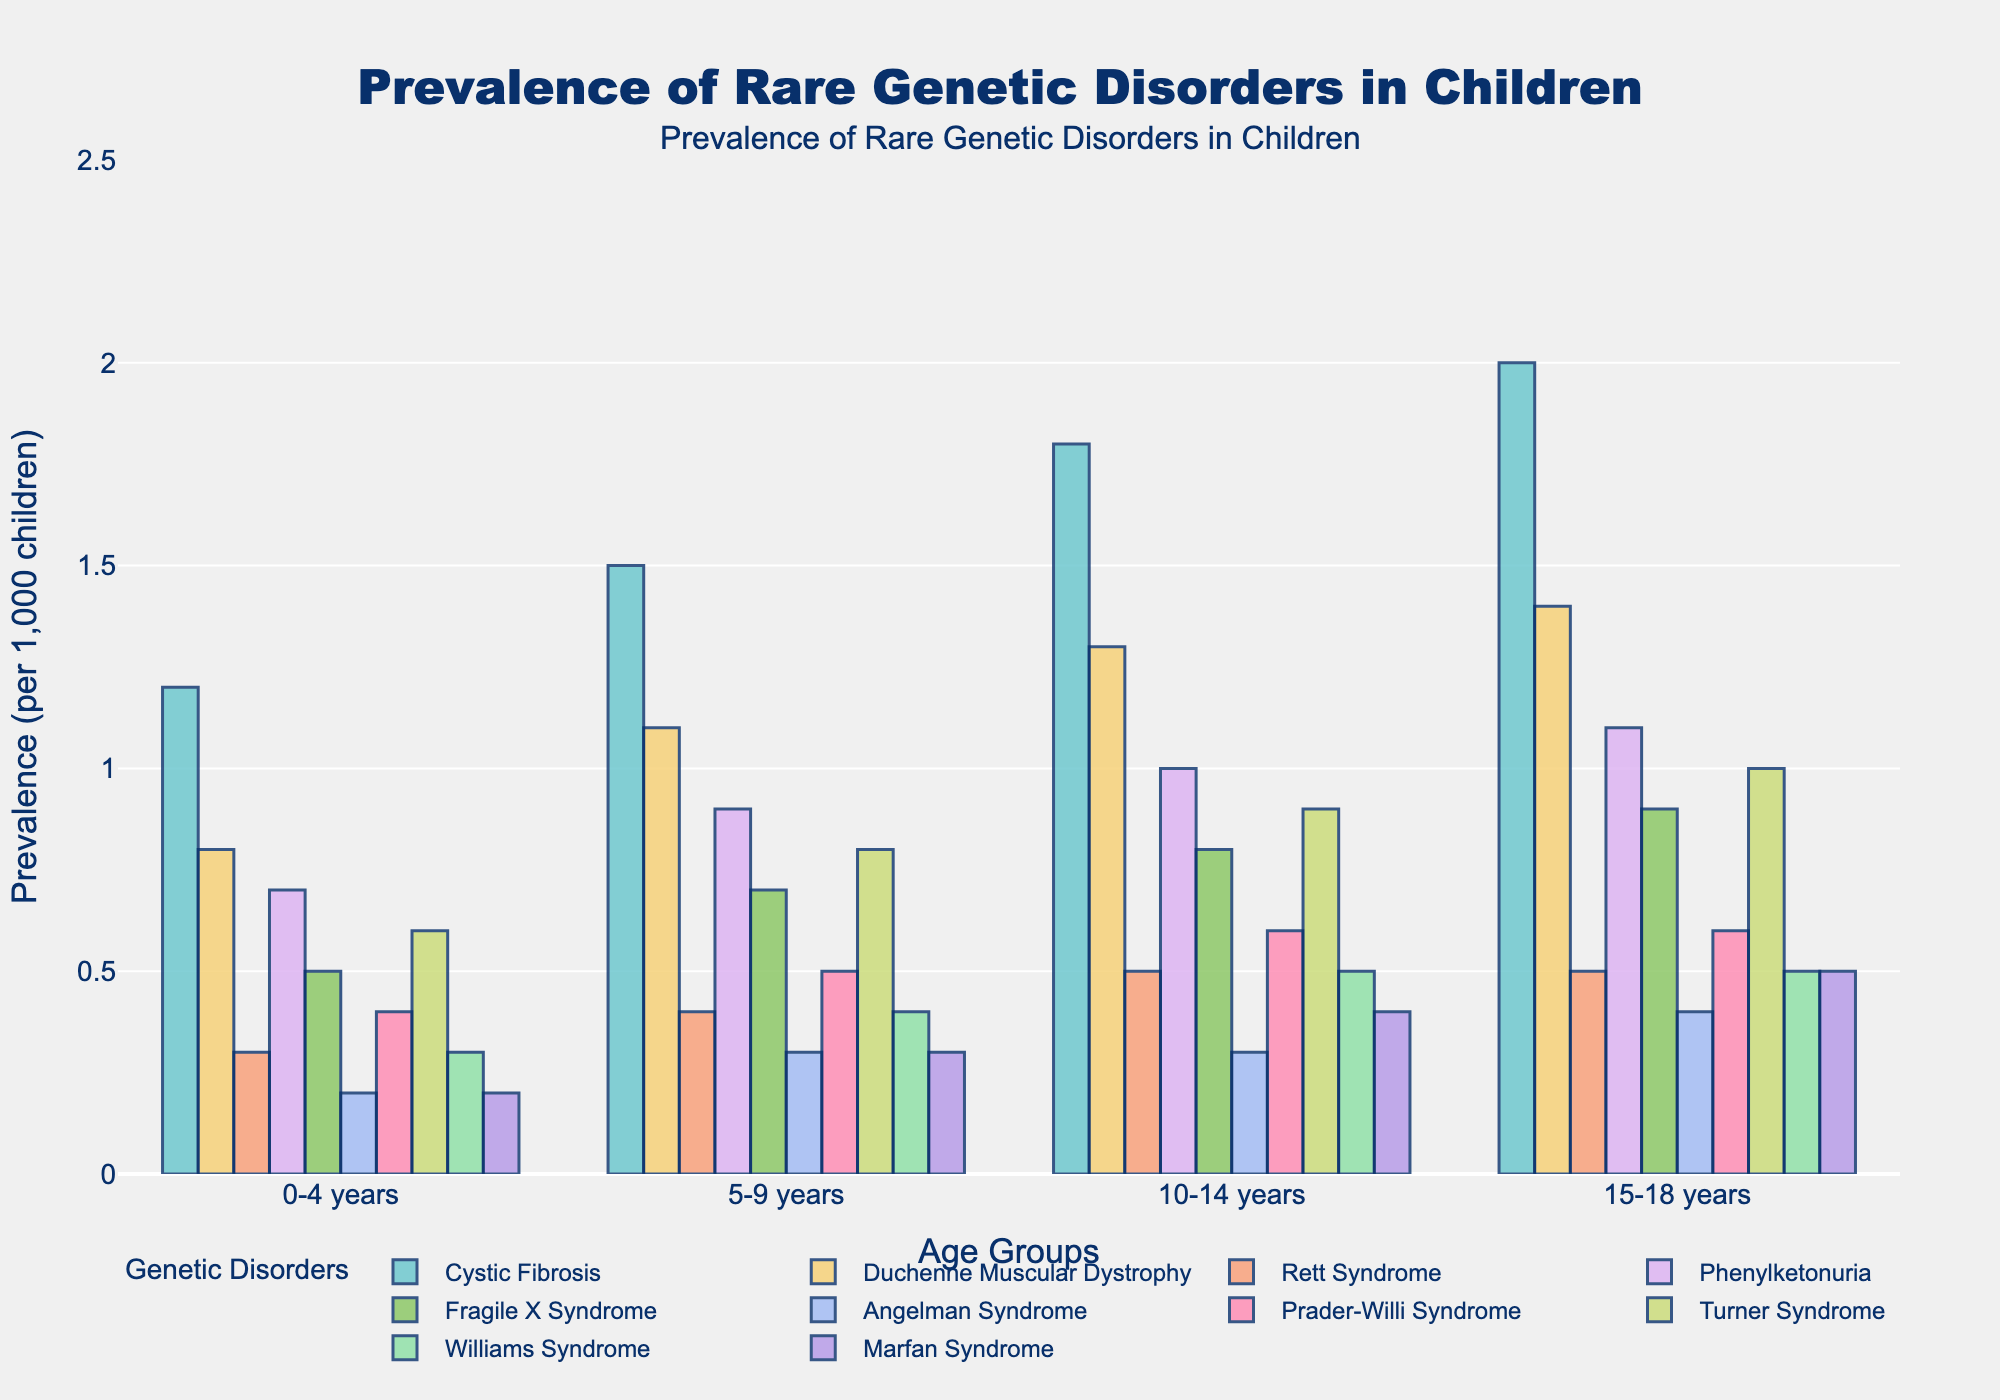How does the prevalence of Cystic Fibrosis change with age from 0-4 years to 15-18 years? To find this, observe the height of the bars representing Cystic Fibrosis across the age groups. The prevalence values increase from 1.2 for 0-4 years, to 1.5 for 5-9 years, to 1.8 for 10-14 years, and finally to 2.0 for 15-18 years. This shows a consistent increase in prevalence with age.
Answer: Increases Which disorder has the highest prevalence in the 15-18 years age group? Check the height of the bars for the 15-18 years age group for each disorder. Cystic Fibrosis has the highest bar with a value of 2.0.
Answer: Cystic Fibrosis Which two disorders have the same prevalence in the 10-14 years age group? Look at the 10-14 years age group and compare the bars. Rett Syndrome and Williams Syndrome both have bars with a height representing a prevalence of 0.5.
Answer: Rett Syndrome and Williams Syndrome What is the average prevalence of Phenylketonuria across all age groups? To compute this, sum up the prevalence values for Phenylketonuria across all age groups (0.7 + 0.9 + 1.0 + 1.1) and divide by 4. The sum is 3.7, and the average is 3.7 / 4 = 0.925.
Answer: 0.925 Is the prevalence of Fragile X Syndrome higher or lower than Turner Syndrome in the 5-9 years age group? Compare the bars representing Fragile X Syndrome and Turner Syndrome in the 5-9 years age group. Fragile X Syndrome has a prevalence of 0.7, while Turner Syndrome has a prevalence of 0.8. Thus, the prevalence of Fragile X Syndrome is lower.
Answer: Lower How much does the prevalence of Duchenne Muscular Dystrophy increase from 0-4 years to 15-18 years? To find this, subtract the prevalence of Duchenne Muscular Dystrophy in the 0-4 years age group (0.8) from its prevalence in the 15-18 years age group (1.4). The difference is 1.4 - 0.8 = 0.6.
Answer: 0.6 What is the total prevalence of Angelman Syndrome across all age groups? To find this, sum up the prevalence values for Angelman Syndrome across all age groups (0.2 + 0.3 + 0.3 + 0.4). The total is 1.2.
Answer: 1.2 Which disorder has a prevalence of 0.5 in the 5-9 years age group? Look for the bar with height 0.5 in the 5-9 years age group. Prader-Willi Syndrome has a prevalence of 0.5 in this age group.
Answer: Prader-Willi Syndrome Which disorder shows the most significant increase from the 0-4 years group to the 5-9 years group? Calculate the increase in prevalence for each disorder from the 0-4 years group to the 5-9 years group and identify the largest difference. For example, Angelman Syndrome increases by 0.3 - 0.2 = 0.1, Cystic Fibrosis increases from 1.2 to 1.5, which is 0.3. Among all disorders, Cystic Fibrosis shows the most significant increase of 0.3.
Answer: Cystic Fibrosis What proportion of disorders have a higher prevalence in the 10-14 years age group compared to the 0-4 years age group? Count the number of disorders, and the number of those that have a higher prevalence in the 10-14 years group than in the 0-4 years group. All disorders show an increase in prevalence from 0-4 to 10-14 years, which is 10 out of 10. Hence, the proportion is 10/10 = 1 or 100%.
Answer: 100% 